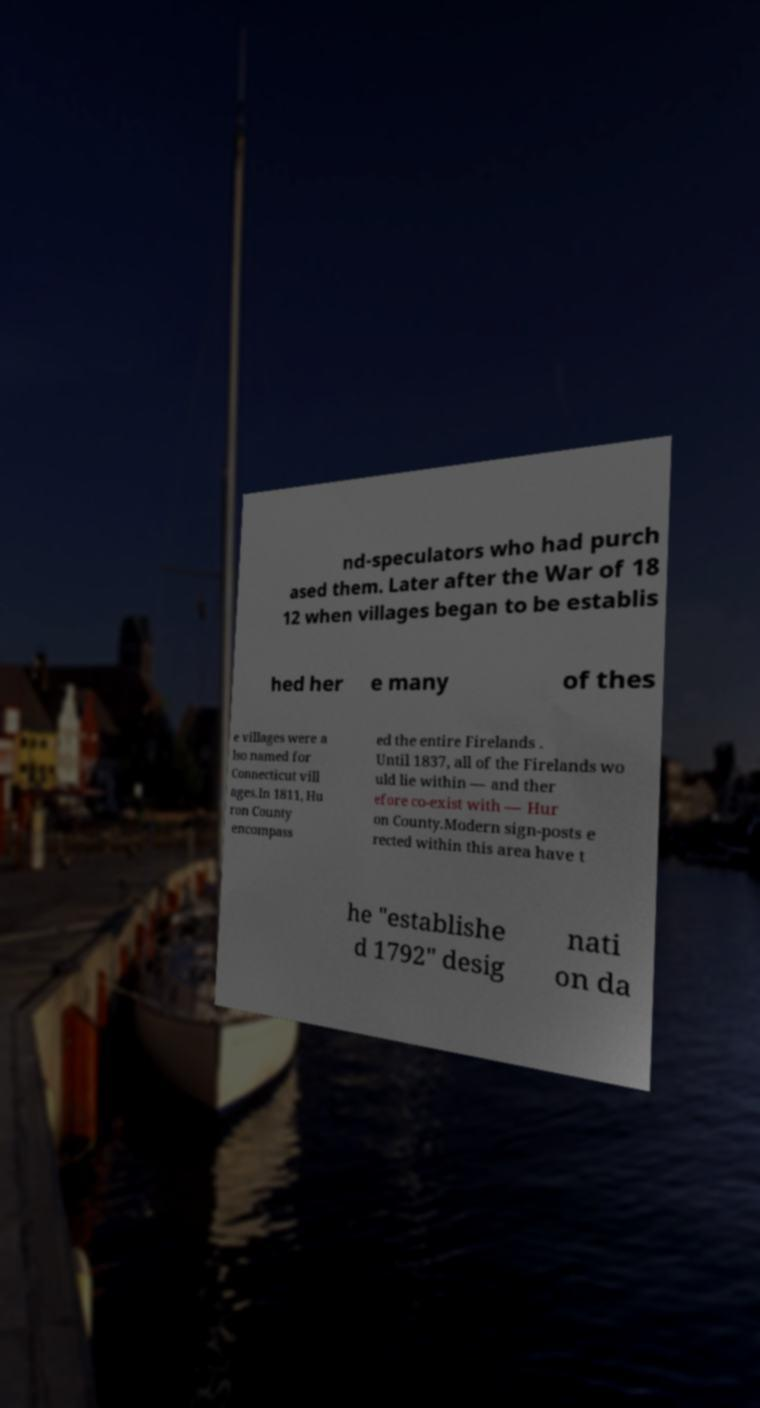Please identify and transcribe the text found in this image. nd-speculators who had purch ased them. Later after the War of 18 12 when villages began to be establis hed her e many of thes e villages were a lso named for Connecticut vill ages.In 1811, Hu ron County encompass ed the entire Firelands . Until 1837, all of the Firelands wo uld lie within — and ther efore co-exist with — Hur on County.Modern sign-posts e rected within this area have t he "establishe d 1792" desig nati on da 